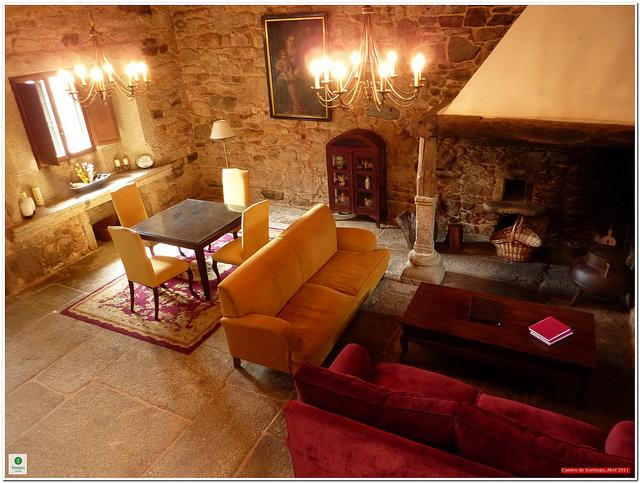How many people can sit at the dining table?
Short answer required. 4. What are the walls of the room made of?
Be succinct. Stone. What is on the coffee table?
Short answer required. Books. 